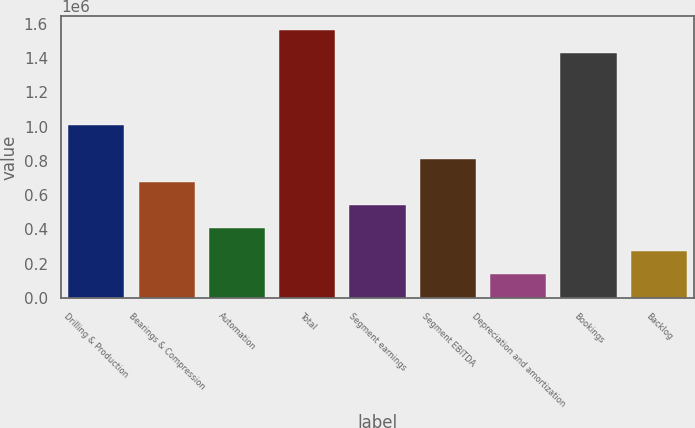Convert chart. <chart><loc_0><loc_0><loc_500><loc_500><bar_chart><fcel>Drilling & Production<fcel>Bearings & Compression<fcel>Automation<fcel>Total<fcel>Segment earnings<fcel>Segment EBITDA<fcel>Depreciation and amortization<fcel>Bookings<fcel>Backlog<nl><fcel>1.00942e+06<fcel>678539<fcel>410159<fcel>1.56345e+06<fcel>544349<fcel>812730<fcel>141779<fcel>1.42926e+06<fcel>275969<nl></chart> 